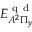<formula> <loc_0><loc_0><loc_500><loc_500>{ E } _ { A ^ { 2 } \Pi _ { y } } ^ { q d }</formula> 